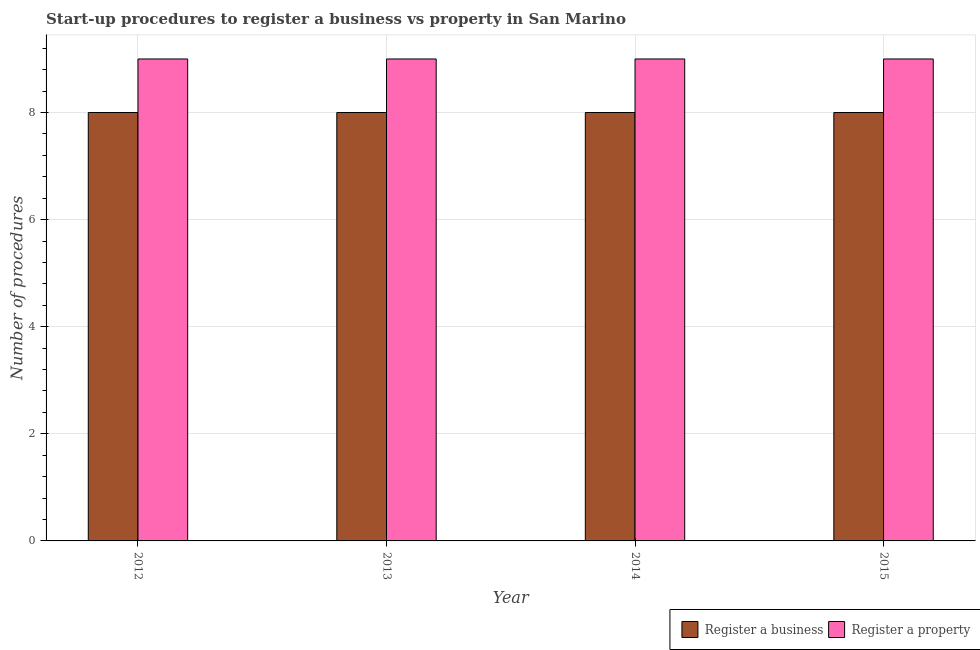Are the number of bars on each tick of the X-axis equal?
Your response must be concise. Yes. How many bars are there on the 3rd tick from the left?
Your answer should be very brief. 2. How many bars are there on the 1st tick from the right?
Your answer should be very brief. 2. What is the label of the 3rd group of bars from the left?
Offer a terse response. 2014. What is the number of procedures to register a property in 2015?
Ensure brevity in your answer.  9. Across all years, what is the maximum number of procedures to register a property?
Offer a very short reply. 9. Across all years, what is the minimum number of procedures to register a property?
Provide a succinct answer. 9. What is the total number of procedures to register a property in the graph?
Your answer should be compact. 36. What is the difference between the number of procedures to register a property in 2012 and the number of procedures to register a business in 2013?
Provide a succinct answer. 0. In the year 2013, what is the difference between the number of procedures to register a business and number of procedures to register a property?
Make the answer very short. 0. In how many years, is the number of procedures to register a property greater than 8.8?
Make the answer very short. 4. What is the ratio of the number of procedures to register a business in 2012 to that in 2014?
Offer a terse response. 1. What does the 1st bar from the left in 2013 represents?
Ensure brevity in your answer.  Register a business. What does the 2nd bar from the right in 2012 represents?
Provide a short and direct response. Register a business. How many bars are there?
Provide a succinct answer. 8. Are all the bars in the graph horizontal?
Offer a very short reply. No. How many years are there in the graph?
Provide a short and direct response. 4. What is the difference between two consecutive major ticks on the Y-axis?
Offer a very short reply. 2. Does the graph contain grids?
Provide a short and direct response. Yes. What is the title of the graph?
Make the answer very short. Start-up procedures to register a business vs property in San Marino. Does "Short-term debt" appear as one of the legend labels in the graph?
Make the answer very short. No. What is the label or title of the X-axis?
Provide a short and direct response. Year. What is the label or title of the Y-axis?
Offer a very short reply. Number of procedures. What is the Number of procedures of Register a business in 2012?
Offer a terse response. 8. What is the Number of procedures in Register a business in 2013?
Provide a short and direct response. 8. What is the Number of procedures of Register a property in 2013?
Give a very brief answer. 9. What is the Number of procedures of Register a property in 2014?
Your response must be concise. 9. Across all years, what is the minimum Number of procedures in Register a business?
Offer a terse response. 8. Across all years, what is the minimum Number of procedures of Register a property?
Offer a terse response. 9. What is the total Number of procedures in Register a business in the graph?
Ensure brevity in your answer.  32. What is the total Number of procedures of Register a property in the graph?
Your answer should be compact. 36. What is the difference between the Number of procedures of Register a business in 2012 and that in 2013?
Provide a short and direct response. 0. What is the difference between the Number of procedures of Register a business in 2012 and that in 2015?
Your answer should be compact. 0. What is the difference between the Number of procedures in Register a property in 2012 and that in 2015?
Make the answer very short. 0. What is the difference between the Number of procedures of Register a business in 2013 and that in 2014?
Provide a succinct answer. 0. What is the difference between the Number of procedures in Register a property in 2013 and that in 2014?
Provide a succinct answer. 0. What is the difference between the Number of procedures in Register a business in 2013 and that in 2015?
Your answer should be very brief. 0. What is the difference between the Number of procedures in Register a property in 2013 and that in 2015?
Keep it short and to the point. 0. What is the difference between the Number of procedures in Register a business in 2014 and that in 2015?
Offer a very short reply. 0. What is the difference between the Number of procedures of Register a business in 2012 and the Number of procedures of Register a property in 2013?
Make the answer very short. -1. What is the difference between the Number of procedures of Register a business in 2012 and the Number of procedures of Register a property in 2014?
Your answer should be very brief. -1. What is the difference between the Number of procedures in Register a business in 2013 and the Number of procedures in Register a property in 2014?
Your answer should be compact. -1. What is the difference between the Number of procedures in Register a business in 2013 and the Number of procedures in Register a property in 2015?
Your response must be concise. -1. What is the average Number of procedures of Register a business per year?
Give a very brief answer. 8. What is the ratio of the Number of procedures in Register a business in 2012 to that in 2014?
Offer a very short reply. 1. What is the ratio of the Number of procedures in Register a property in 2012 to that in 2014?
Keep it short and to the point. 1. What is the ratio of the Number of procedures in Register a business in 2013 to that in 2014?
Your answer should be very brief. 1. What is the ratio of the Number of procedures of Register a property in 2013 to that in 2015?
Provide a short and direct response. 1. What is the ratio of the Number of procedures of Register a business in 2014 to that in 2015?
Make the answer very short. 1. 